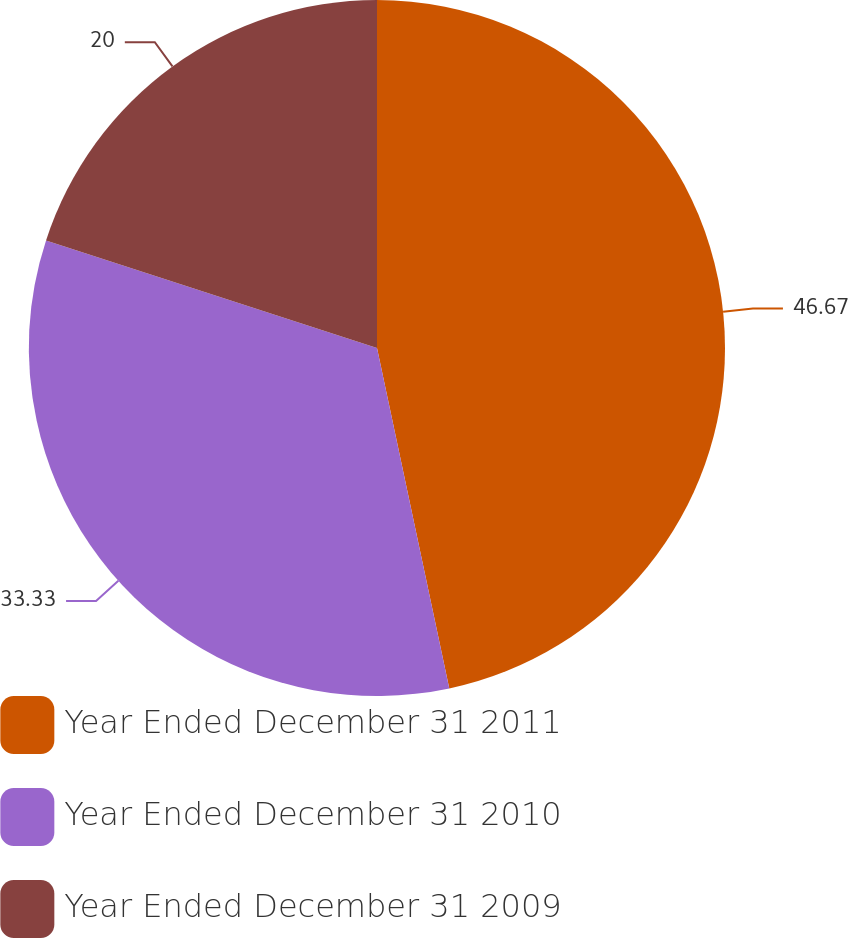<chart> <loc_0><loc_0><loc_500><loc_500><pie_chart><fcel>Year Ended December 31 2011<fcel>Year Ended December 31 2010<fcel>Year Ended December 31 2009<nl><fcel>46.67%<fcel>33.33%<fcel>20.0%<nl></chart> 